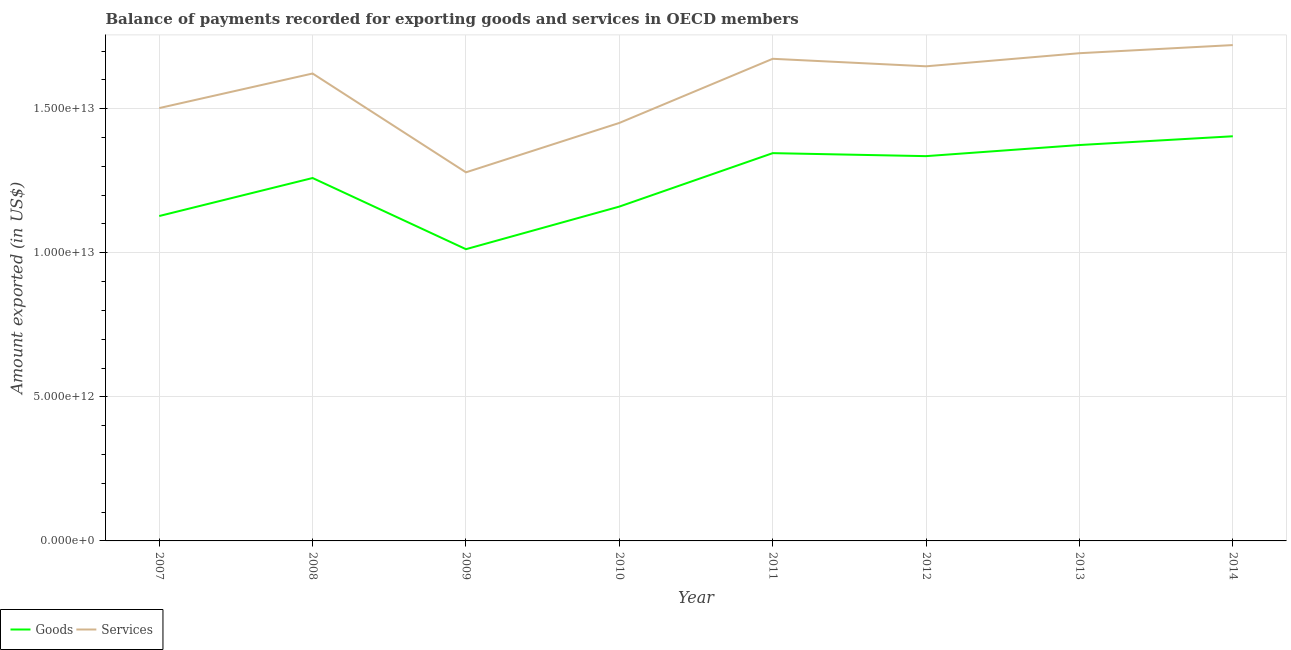How many different coloured lines are there?
Offer a very short reply. 2. What is the amount of services exported in 2011?
Ensure brevity in your answer.  1.67e+13. Across all years, what is the maximum amount of goods exported?
Ensure brevity in your answer.  1.40e+13. Across all years, what is the minimum amount of goods exported?
Your response must be concise. 1.01e+13. In which year was the amount of services exported maximum?
Offer a terse response. 2014. In which year was the amount of goods exported minimum?
Offer a terse response. 2009. What is the total amount of goods exported in the graph?
Offer a very short reply. 1.00e+14. What is the difference between the amount of goods exported in 2012 and that in 2013?
Provide a succinct answer. -3.86e+11. What is the difference between the amount of services exported in 2007 and the amount of goods exported in 2011?
Make the answer very short. 1.56e+12. What is the average amount of goods exported per year?
Give a very brief answer. 1.25e+13. In the year 2011, what is the difference between the amount of services exported and amount of goods exported?
Provide a succinct answer. 3.27e+12. In how many years, is the amount of services exported greater than 6000000000000 US$?
Give a very brief answer. 8. What is the ratio of the amount of services exported in 2010 to that in 2014?
Give a very brief answer. 0.84. What is the difference between the highest and the second highest amount of goods exported?
Your answer should be very brief. 3.04e+11. What is the difference between the highest and the lowest amount of goods exported?
Your answer should be very brief. 3.92e+12. In how many years, is the amount of services exported greater than the average amount of services exported taken over all years?
Give a very brief answer. 5. Is the amount of goods exported strictly less than the amount of services exported over the years?
Give a very brief answer. Yes. How many lines are there?
Your response must be concise. 2. How many years are there in the graph?
Keep it short and to the point. 8. What is the difference between two consecutive major ticks on the Y-axis?
Offer a very short reply. 5.00e+12. Are the values on the major ticks of Y-axis written in scientific E-notation?
Give a very brief answer. Yes. Does the graph contain grids?
Your response must be concise. Yes. How are the legend labels stacked?
Keep it short and to the point. Horizontal. What is the title of the graph?
Your answer should be compact. Balance of payments recorded for exporting goods and services in OECD members. What is the label or title of the Y-axis?
Ensure brevity in your answer.  Amount exported (in US$). What is the Amount exported (in US$) of Goods in 2007?
Offer a very short reply. 1.13e+13. What is the Amount exported (in US$) of Services in 2007?
Give a very brief answer. 1.50e+13. What is the Amount exported (in US$) of Goods in 2008?
Your answer should be compact. 1.26e+13. What is the Amount exported (in US$) in Services in 2008?
Offer a very short reply. 1.62e+13. What is the Amount exported (in US$) of Goods in 2009?
Offer a very short reply. 1.01e+13. What is the Amount exported (in US$) of Services in 2009?
Ensure brevity in your answer.  1.28e+13. What is the Amount exported (in US$) of Goods in 2010?
Keep it short and to the point. 1.16e+13. What is the Amount exported (in US$) of Services in 2010?
Your response must be concise. 1.45e+13. What is the Amount exported (in US$) in Goods in 2011?
Keep it short and to the point. 1.35e+13. What is the Amount exported (in US$) in Services in 2011?
Offer a very short reply. 1.67e+13. What is the Amount exported (in US$) of Goods in 2012?
Give a very brief answer. 1.34e+13. What is the Amount exported (in US$) of Services in 2012?
Provide a short and direct response. 1.65e+13. What is the Amount exported (in US$) in Goods in 2013?
Keep it short and to the point. 1.37e+13. What is the Amount exported (in US$) in Services in 2013?
Keep it short and to the point. 1.69e+13. What is the Amount exported (in US$) in Goods in 2014?
Make the answer very short. 1.40e+13. What is the Amount exported (in US$) in Services in 2014?
Ensure brevity in your answer.  1.72e+13. Across all years, what is the maximum Amount exported (in US$) of Goods?
Make the answer very short. 1.40e+13. Across all years, what is the maximum Amount exported (in US$) of Services?
Your answer should be compact. 1.72e+13. Across all years, what is the minimum Amount exported (in US$) of Goods?
Provide a succinct answer. 1.01e+13. Across all years, what is the minimum Amount exported (in US$) of Services?
Give a very brief answer. 1.28e+13. What is the total Amount exported (in US$) of Goods in the graph?
Ensure brevity in your answer.  1.00e+14. What is the total Amount exported (in US$) in Services in the graph?
Keep it short and to the point. 1.26e+14. What is the difference between the Amount exported (in US$) in Goods in 2007 and that in 2008?
Keep it short and to the point. -1.32e+12. What is the difference between the Amount exported (in US$) in Services in 2007 and that in 2008?
Your answer should be compact. -1.20e+12. What is the difference between the Amount exported (in US$) of Goods in 2007 and that in 2009?
Ensure brevity in your answer.  1.15e+12. What is the difference between the Amount exported (in US$) of Services in 2007 and that in 2009?
Provide a short and direct response. 2.23e+12. What is the difference between the Amount exported (in US$) in Goods in 2007 and that in 2010?
Your answer should be very brief. -3.28e+11. What is the difference between the Amount exported (in US$) of Services in 2007 and that in 2010?
Provide a short and direct response. 5.16e+11. What is the difference between the Amount exported (in US$) of Goods in 2007 and that in 2011?
Ensure brevity in your answer.  -2.18e+12. What is the difference between the Amount exported (in US$) in Services in 2007 and that in 2011?
Give a very brief answer. -1.71e+12. What is the difference between the Amount exported (in US$) of Goods in 2007 and that in 2012?
Provide a short and direct response. -2.08e+12. What is the difference between the Amount exported (in US$) in Services in 2007 and that in 2012?
Your answer should be compact. -1.45e+12. What is the difference between the Amount exported (in US$) of Goods in 2007 and that in 2013?
Your answer should be compact. -2.46e+12. What is the difference between the Amount exported (in US$) in Services in 2007 and that in 2013?
Offer a very short reply. -1.90e+12. What is the difference between the Amount exported (in US$) of Goods in 2007 and that in 2014?
Provide a succinct answer. -2.77e+12. What is the difference between the Amount exported (in US$) of Services in 2007 and that in 2014?
Offer a very short reply. -2.19e+12. What is the difference between the Amount exported (in US$) in Goods in 2008 and that in 2009?
Offer a very short reply. 2.47e+12. What is the difference between the Amount exported (in US$) in Services in 2008 and that in 2009?
Make the answer very short. 3.43e+12. What is the difference between the Amount exported (in US$) of Goods in 2008 and that in 2010?
Keep it short and to the point. 9.91e+11. What is the difference between the Amount exported (in US$) in Services in 2008 and that in 2010?
Give a very brief answer. 1.72e+12. What is the difference between the Amount exported (in US$) in Goods in 2008 and that in 2011?
Provide a short and direct response. -8.63e+11. What is the difference between the Amount exported (in US$) in Services in 2008 and that in 2011?
Give a very brief answer. -5.11e+11. What is the difference between the Amount exported (in US$) in Goods in 2008 and that in 2012?
Provide a succinct answer. -7.59e+11. What is the difference between the Amount exported (in US$) of Services in 2008 and that in 2012?
Your answer should be compact. -2.50e+11. What is the difference between the Amount exported (in US$) in Goods in 2008 and that in 2013?
Make the answer very short. -1.14e+12. What is the difference between the Amount exported (in US$) of Services in 2008 and that in 2013?
Provide a succinct answer. -7.05e+11. What is the difference between the Amount exported (in US$) in Goods in 2008 and that in 2014?
Your answer should be very brief. -1.45e+12. What is the difference between the Amount exported (in US$) in Services in 2008 and that in 2014?
Ensure brevity in your answer.  -9.87e+11. What is the difference between the Amount exported (in US$) of Goods in 2009 and that in 2010?
Ensure brevity in your answer.  -1.48e+12. What is the difference between the Amount exported (in US$) of Services in 2009 and that in 2010?
Provide a succinct answer. -1.71e+12. What is the difference between the Amount exported (in US$) of Goods in 2009 and that in 2011?
Give a very brief answer. -3.33e+12. What is the difference between the Amount exported (in US$) of Services in 2009 and that in 2011?
Provide a short and direct response. -3.94e+12. What is the difference between the Amount exported (in US$) in Goods in 2009 and that in 2012?
Provide a short and direct response. -3.23e+12. What is the difference between the Amount exported (in US$) of Services in 2009 and that in 2012?
Provide a short and direct response. -3.68e+12. What is the difference between the Amount exported (in US$) in Goods in 2009 and that in 2013?
Offer a terse response. -3.61e+12. What is the difference between the Amount exported (in US$) of Services in 2009 and that in 2013?
Your answer should be very brief. -4.13e+12. What is the difference between the Amount exported (in US$) of Goods in 2009 and that in 2014?
Your answer should be compact. -3.92e+12. What is the difference between the Amount exported (in US$) of Services in 2009 and that in 2014?
Provide a short and direct response. -4.42e+12. What is the difference between the Amount exported (in US$) in Goods in 2010 and that in 2011?
Give a very brief answer. -1.85e+12. What is the difference between the Amount exported (in US$) in Services in 2010 and that in 2011?
Keep it short and to the point. -2.23e+12. What is the difference between the Amount exported (in US$) in Goods in 2010 and that in 2012?
Offer a terse response. -1.75e+12. What is the difference between the Amount exported (in US$) in Services in 2010 and that in 2012?
Your answer should be very brief. -1.97e+12. What is the difference between the Amount exported (in US$) in Goods in 2010 and that in 2013?
Provide a succinct answer. -2.14e+12. What is the difference between the Amount exported (in US$) in Services in 2010 and that in 2013?
Offer a terse response. -2.42e+12. What is the difference between the Amount exported (in US$) of Goods in 2010 and that in 2014?
Your answer should be very brief. -2.44e+12. What is the difference between the Amount exported (in US$) in Services in 2010 and that in 2014?
Offer a terse response. -2.70e+12. What is the difference between the Amount exported (in US$) in Goods in 2011 and that in 2012?
Your response must be concise. 1.04e+11. What is the difference between the Amount exported (in US$) of Services in 2011 and that in 2012?
Keep it short and to the point. 2.61e+11. What is the difference between the Amount exported (in US$) in Goods in 2011 and that in 2013?
Keep it short and to the point. -2.82e+11. What is the difference between the Amount exported (in US$) of Services in 2011 and that in 2013?
Ensure brevity in your answer.  -1.94e+11. What is the difference between the Amount exported (in US$) in Goods in 2011 and that in 2014?
Your answer should be very brief. -5.86e+11. What is the difference between the Amount exported (in US$) of Services in 2011 and that in 2014?
Your response must be concise. -4.76e+11. What is the difference between the Amount exported (in US$) in Goods in 2012 and that in 2013?
Ensure brevity in your answer.  -3.86e+11. What is the difference between the Amount exported (in US$) in Services in 2012 and that in 2013?
Offer a very short reply. -4.54e+11. What is the difference between the Amount exported (in US$) of Goods in 2012 and that in 2014?
Your answer should be compact. -6.90e+11. What is the difference between the Amount exported (in US$) in Services in 2012 and that in 2014?
Your answer should be compact. -7.37e+11. What is the difference between the Amount exported (in US$) of Goods in 2013 and that in 2014?
Your response must be concise. -3.04e+11. What is the difference between the Amount exported (in US$) in Services in 2013 and that in 2014?
Make the answer very short. -2.82e+11. What is the difference between the Amount exported (in US$) in Goods in 2007 and the Amount exported (in US$) in Services in 2008?
Keep it short and to the point. -4.95e+12. What is the difference between the Amount exported (in US$) of Goods in 2007 and the Amount exported (in US$) of Services in 2009?
Provide a succinct answer. -1.52e+12. What is the difference between the Amount exported (in US$) in Goods in 2007 and the Amount exported (in US$) in Services in 2010?
Your answer should be very brief. -3.23e+12. What is the difference between the Amount exported (in US$) in Goods in 2007 and the Amount exported (in US$) in Services in 2011?
Provide a short and direct response. -5.46e+12. What is the difference between the Amount exported (in US$) in Goods in 2007 and the Amount exported (in US$) in Services in 2012?
Your response must be concise. -5.20e+12. What is the difference between the Amount exported (in US$) in Goods in 2007 and the Amount exported (in US$) in Services in 2013?
Keep it short and to the point. -5.65e+12. What is the difference between the Amount exported (in US$) in Goods in 2007 and the Amount exported (in US$) in Services in 2014?
Provide a short and direct response. -5.93e+12. What is the difference between the Amount exported (in US$) in Goods in 2008 and the Amount exported (in US$) in Services in 2009?
Keep it short and to the point. -1.97e+11. What is the difference between the Amount exported (in US$) in Goods in 2008 and the Amount exported (in US$) in Services in 2010?
Offer a terse response. -1.91e+12. What is the difference between the Amount exported (in US$) of Goods in 2008 and the Amount exported (in US$) of Services in 2011?
Your answer should be compact. -4.14e+12. What is the difference between the Amount exported (in US$) of Goods in 2008 and the Amount exported (in US$) of Services in 2012?
Your answer should be very brief. -3.88e+12. What is the difference between the Amount exported (in US$) of Goods in 2008 and the Amount exported (in US$) of Services in 2013?
Make the answer very short. -4.33e+12. What is the difference between the Amount exported (in US$) in Goods in 2008 and the Amount exported (in US$) in Services in 2014?
Offer a terse response. -4.61e+12. What is the difference between the Amount exported (in US$) of Goods in 2009 and the Amount exported (in US$) of Services in 2010?
Keep it short and to the point. -4.38e+12. What is the difference between the Amount exported (in US$) of Goods in 2009 and the Amount exported (in US$) of Services in 2011?
Your response must be concise. -6.61e+12. What is the difference between the Amount exported (in US$) of Goods in 2009 and the Amount exported (in US$) of Services in 2012?
Your answer should be compact. -6.35e+12. What is the difference between the Amount exported (in US$) in Goods in 2009 and the Amount exported (in US$) in Services in 2013?
Your answer should be very brief. -6.80e+12. What is the difference between the Amount exported (in US$) in Goods in 2009 and the Amount exported (in US$) in Services in 2014?
Provide a succinct answer. -7.08e+12. What is the difference between the Amount exported (in US$) of Goods in 2010 and the Amount exported (in US$) of Services in 2011?
Give a very brief answer. -5.13e+12. What is the difference between the Amount exported (in US$) in Goods in 2010 and the Amount exported (in US$) in Services in 2012?
Your response must be concise. -4.87e+12. What is the difference between the Amount exported (in US$) of Goods in 2010 and the Amount exported (in US$) of Services in 2013?
Keep it short and to the point. -5.32e+12. What is the difference between the Amount exported (in US$) in Goods in 2010 and the Amount exported (in US$) in Services in 2014?
Provide a succinct answer. -5.61e+12. What is the difference between the Amount exported (in US$) in Goods in 2011 and the Amount exported (in US$) in Services in 2012?
Give a very brief answer. -3.01e+12. What is the difference between the Amount exported (in US$) of Goods in 2011 and the Amount exported (in US$) of Services in 2013?
Offer a very short reply. -3.47e+12. What is the difference between the Amount exported (in US$) in Goods in 2011 and the Amount exported (in US$) in Services in 2014?
Offer a terse response. -3.75e+12. What is the difference between the Amount exported (in US$) of Goods in 2012 and the Amount exported (in US$) of Services in 2013?
Your response must be concise. -3.57e+12. What is the difference between the Amount exported (in US$) of Goods in 2012 and the Amount exported (in US$) of Services in 2014?
Provide a short and direct response. -3.85e+12. What is the difference between the Amount exported (in US$) in Goods in 2013 and the Amount exported (in US$) in Services in 2014?
Your answer should be very brief. -3.47e+12. What is the average Amount exported (in US$) of Goods per year?
Provide a short and direct response. 1.25e+13. What is the average Amount exported (in US$) of Services per year?
Ensure brevity in your answer.  1.57e+13. In the year 2007, what is the difference between the Amount exported (in US$) of Goods and Amount exported (in US$) of Services?
Give a very brief answer. -3.75e+12. In the year 2008, what is the difference between the Amount exported (in US$) of Goods and Amount exported (in US$) of Services?
Keep it short and to the point. -3.63e+12. In the year 2009, what is the difference between the Amount exported (in US$) of Goods and Amount exported (in US$) of Services?
Your response must be concise. -2.67e+12. In the year 2010, what is the difference between the Amount exported (in US$) of Goods and Amount exported (in US$) of Services?
Your answer should be compact. -2.90e+12. In the year 2011, what is the difference between the Amount exported (in US$) of Goods and Amount exported (in US$) of Services?
Give a very brief answer. -3.27e+12. In the year 2012, what is the difference between the Amount exported (in US$) in Goods and Amount exported (in US$) in Services?
Offer a terse response. -3.12e+12. In the year 2013, what is the difference between the Amount exported (in US$) of Goods and Amount exported (in US$) of Services?
Give a very brief answer. -3.19e+12. In the year 2014, what is the difference between the Amount exported (in US$) in Goods and Amount exported (in US$) in Services?
Provide a short and direct response. -3.16e+12. What is the ratio of the Amount exported (in US$) in Goods in 2007 to that in 2008?
Provide a succinct answer. 0.9. What is the ratio of the Amount exported (in US$) of Services in 2007 to that in 2008?
Make the answer very short. 0.93. What is the ratio of the Amount exported (in US$) of Goods in 2007 to that in 2009?
Provide a succinct answer. 1.11. What is the ratio of the Amount exported (in US$) of Services in 2007 to that in 2009?
Your answer should be compact. 1.17. What is the ratio of the Amount exported (in US$) in Goods in 2007 to that in 2010?
Your response must be concise. 0.97. What is the ratio of the Amount exported (in US$) in Services in 2007 to that in 2010?
Offer a very short reply. 1.04. What is the ratio of the Amount exported (in US$) of Goods in 2007 to that in 2011?
Your answer should be very brief. 0.84. What is the ratio of the Amount exported (in US$) in Services in 2007 to that in 2011?
Keep it short and to the point. 0.9. What is the ratio of the Amount exported (in US$) in Goods in 2007 to that in 2012?
Your answer should be very brief. 0.84. What is the ratio of the Amount exported (in US$) in Services in 2007 to that in 2012?
Provide a short and direct response. 0.91. What is the ratio of the Amount exported (in US$) of Goods in 2007 to that in 2013?
Provide a succinct answer. 0.82. What is the ratio of the Amount exported (in US$) in Services in 2007 to that in 2013?
Ensure brevity in your answer.  0.89. What is the ratio of the Amount exported (in US$) in Goods in 2007 to that in 2014?
Keep it short and to the point. 0.8. What is the ratio of the Amount exported (in US$) of Services in 2007 to that in 2014?
Provide a succinct answer. 0.87. What is the ratio of the Amount exported (in US$) in Goods in 2008 to that in 2009?
Keep it short and to the point. 1.24. What is the ratio of the Amount exported (in US$) of Services in 2008 to that in 2009?
Keep it short and to the point. 1.27. What is the ratio of the Amount exported (in US$) in Goods in 2008 to that in 2010?
Ensure brevity in your answer.  1.09. What is the ratio of the Amount exported (in US$) of Services in 2008 to that in 2010?
Your answer should be very brief. 1.12. What is the ratio of the Amount exported (in US$) in Goods in 2008 to that in 2011?
Offer a terse response. 0.94. What is the ratio of the Amount exported (in US$) of Services in 2008 to that in 2011?
Give a very brief answer. 0.97. What is the ratio of the Amount exported (in US$) in Goods in 2008 to that in 2012?
Offer a very short reply. 0.94. What is the ratio of the Amount exported (in US$) of Goods in 2008 to that in 2013?
Ensure brevity in your answer.  0.92. What is the ratio of the Amount exported (in US$) of Services in 2008 to that in 2013?
Provide a short and direct response. 0.96. What is the ratio of the Amount exported (in US$) of Goods in 2008 to that in 2014?
Provide a succinct answer. 0.9. What is the ratio of the Amount exported (in US$) of Services in 2008 to that in 2014?
Your response must be concise. 0.94. What is the ratio of the Amount exported (in US$) of Goods in 2009 to that in 2010?
Provide a succinct answer. 0.87. What is the ratio of the Amount exported (in US$) in Services in 2009 to that in 2010?
Offer a terse response. 0.88. What is the ratio of the Amount exported (in US$) of Goods in 2009 to that in 2011?
Offer a very short reply. 0.75. What is the ratio of the Amount exported (in US$) of Services in 2009 to that in 2011?
Provide a succinct answer. 0.76. What is the ratio of the Amount exported (in US$) in Goods in 2009 to that in 2012?
Give a very brief answer. 0.76. What is the ratio of the Amount exported (in US$) of Services in 2009 to that in 2012?
Your response must be concise. 0.78. What is the ratio of the Amount exported (in US$) in Goods in 2009 to that in 2013?
Keep it short and to the point. 0.74. What is the ratio of the Amount exported (in US$) in Services in 2009 to that in 2013?
Your answer should be compact. 0.76. What is the ratio of the Amount exported (in US$) of Goods in 2009 to that in 2014?
Offer a very short reply. 0.72. What is the ratio of the Amount exported (in US$) in Services in 2009 to that in 2014?
Your response must be concise. 0.74. What is the ratio of the Amount exported (in US$) in Goods in 2010 to that in 2011?
Your response must be concise. 0.86. What is the ratio of the Amount exported (in US$) of Services in 2010 to that in 2011?
Ensure brevity in your answer.  0.87. What is the ratio of the Amount exported (in US$) of Goods in 2010 to that in 2012?
Make the answer very short. 0.87. What is the ratio of the Amount exported (in US$) of Services in 2010 to that in 2012?
Provide a succinct answer. 0.88. What is the ratio of the Amount exported (in US$) of Goods in 2010 to that in 2013?
Make the answer very short. 0.84. What is the ratio of the Amount exported (in US$) in Services in 2010 to that in 2013?
Offer a terse response. 0.86. What is the ratio of the Amount exported (in US$) in Goods in 2010 to that in 2014?
Offer a very short reply. 0.83. What is the ratio of the Amount exported (in US$) of Services in 2010 to that in 2014?
Your answer should be very brief. 0.84. What is the ratio of the Amount exported (in US$) in Goods in 2011 to that in 2012?
Your answer should be compact. 1.01. What is the ratio of the Amount exported (in US$) in Services in 2011 to that in 2012?
Provide a succinct answer. 1.02. What is the ratio of the Amount exported (in US$) of Goods in 2011 to that in 2013?
Provide a short and direct response. 0.98. What is the ratio of the Amount exported (in US$) of Goods in 2011 to that in 2014?
Make the answer very short. 0.96. What is the ratio of the Amount exported (in US$) in Services in 2011 to that in 2014?
Provide a succinct answer. 0.97. What is the ratio of the Amount exported (in US$) in Goods in 2012 to that in 2013?
Offer a terse response. 0.97. What is the ratio of the Amount exported (in US$) of Services in 2012 to that in 2013?
Your response must be concise. 0.97. What is the ratio of the Amount exported (in US$) in Goods in 2012 to that in 2014?
Provide a short and direct response. 0.95. What is the ratio of the Amount exported (in US$) in Services in 2012 to that in 2014?
Offer a terse response. 0.96. What is the ratio of the Amount exported (in US$) in Goods in 2013 to that in 2014?
Your answer should be compact. 0.98. What is the ratio of the Amount exported (in US$) in Services in 2013 to that in 2014?
Offer a terse response. 0.98. What is the difference between the highest and the second highest Amount exported (in US$) in Goods?
Provide a succinct answer. 3.04e+11. What is the difference between the highest and the second highest Amount exported (in US$) of Services?
Ensure brevity in your answer.  2.82e+11. What is the difference between the highest and the lowest Amount exported (in US$) of Goods?
Provide a short and direct response. 3.92e+12. What is the difference between the highest and the lowest Amount exported (in US$) of Services?
Provide a short and direct response. 4.42e+12. 